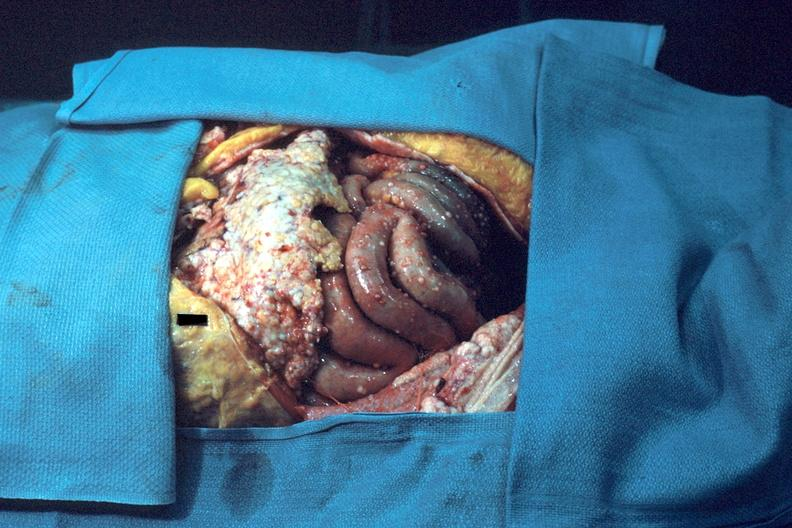where is this area in the body?
Answer the question using a single word or phrase. Abdomen 